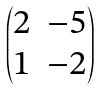<formula> <loc_0><loc_0><loc_500><loc_500>\begin{pmatrix} 2 & - 5 \\ 1 & - 2 \end{pmatrix}</formula> 